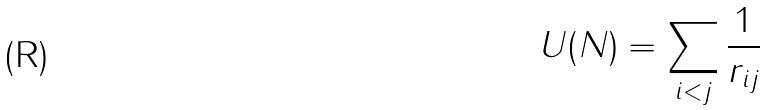<formula> <loc_0><loc_0><loc_500><loc_500>U ( N ) = \sum _ { i < j } \frac { 1 } { r _ { i j } }</formula> 